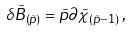<formula> <loc_0><loc_0><loc_500><loc_500>\delta \tilde { B } _ { ( \tilde { p } ) } = \tilde { p } \partial \tilde { \chi } _ { ( \tilde { p } - 1 ) } \, ,</formula> 